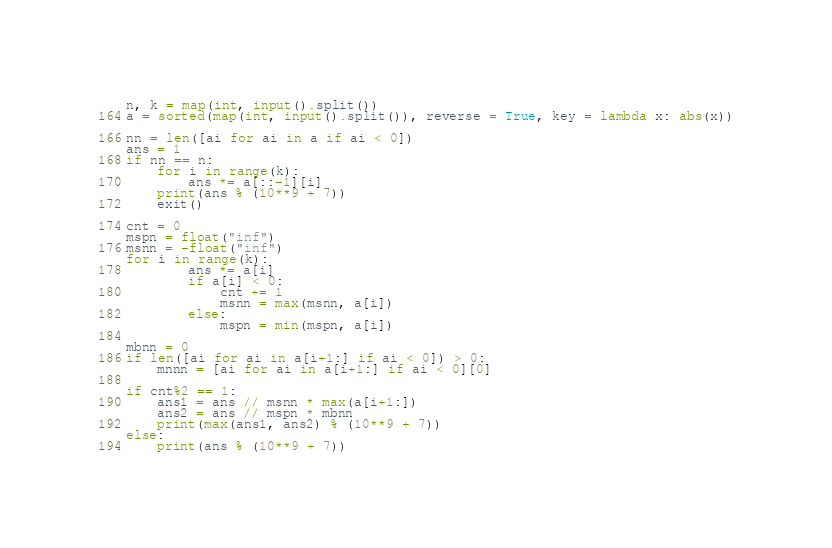Convert code to text. <code><loc_0><loc_0><loc_500><loc_500><_Python_>n, k = map(int, input().split())
a = sorted(map(int, input().split()), reverse = True, key = lambda x: abs(x))

nn = len([ai for ai in a if ai < 0])
ans = 1
if nn == n:
    for i in range(k):
        ans *= a[::-1][i]
    print(ans % (10**9 + 7))
    exit()

cnt = 0
mspn = float("inf")
msnn = -float("inf")
for i in range(k):
        ans *= a[i]
        if a[i] < 0:
            cnt += 1
            msnn = max(msnn, a[i])
        else:
            mspn = min(mspn, a[i])

mbnn = 0
if len([ai for ai in a[i+1:] if ai < 0]) > 0:
    mnnn = [ai for ai in a[i+1:] if ai < 0][0]
    
if cnt%2 == 1:
    ans1 = ans // msnn * max(a[i+1:])
    ans2 = ans // mspn * mbnn
    print(max(ans1, ans2) % (10**9 + 7))
else:
    print(ans % (10**9 + 7))</code> 